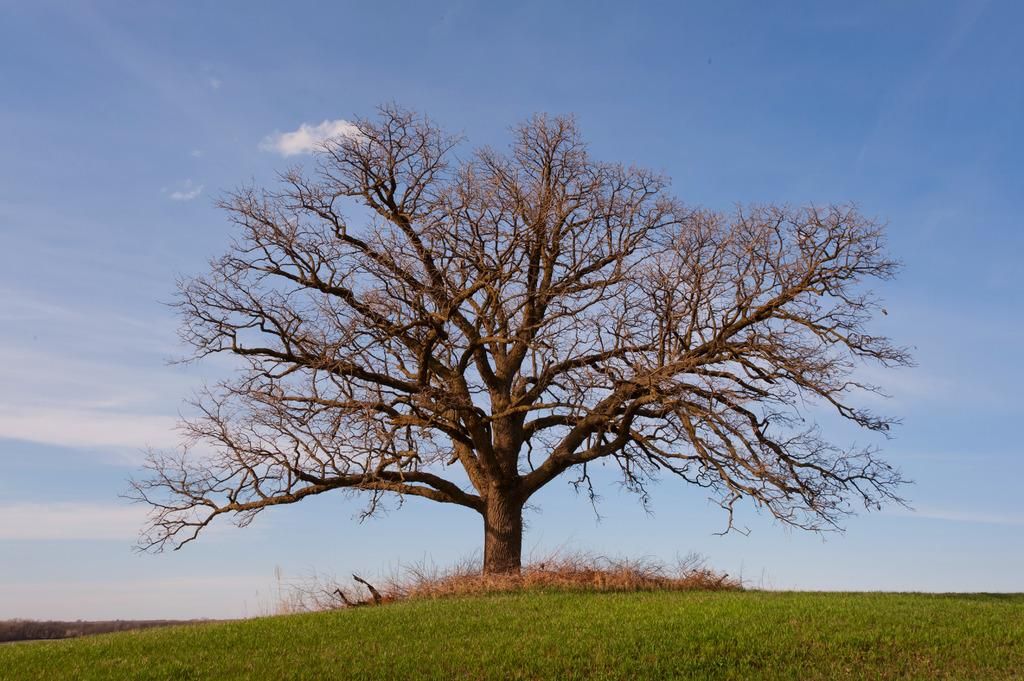What is the main subject in the center of the image? There is a tree in the center of the image. What can be seen at the bottom of the image? There are plants and grass at the bottom of the image. What is visible in the sky at the top of the image? Clouds are present in the sky at the top of the image. How many lizards can be seen climbing on the tree in the image? There are no lizards present in the image; it only features a tree, plants, grass, and clouds. Is the grandfather sitting under the tree in the image? There is no mention of a grandfather or any person in the image; it only features a tree, plants, grass, and clouds. 